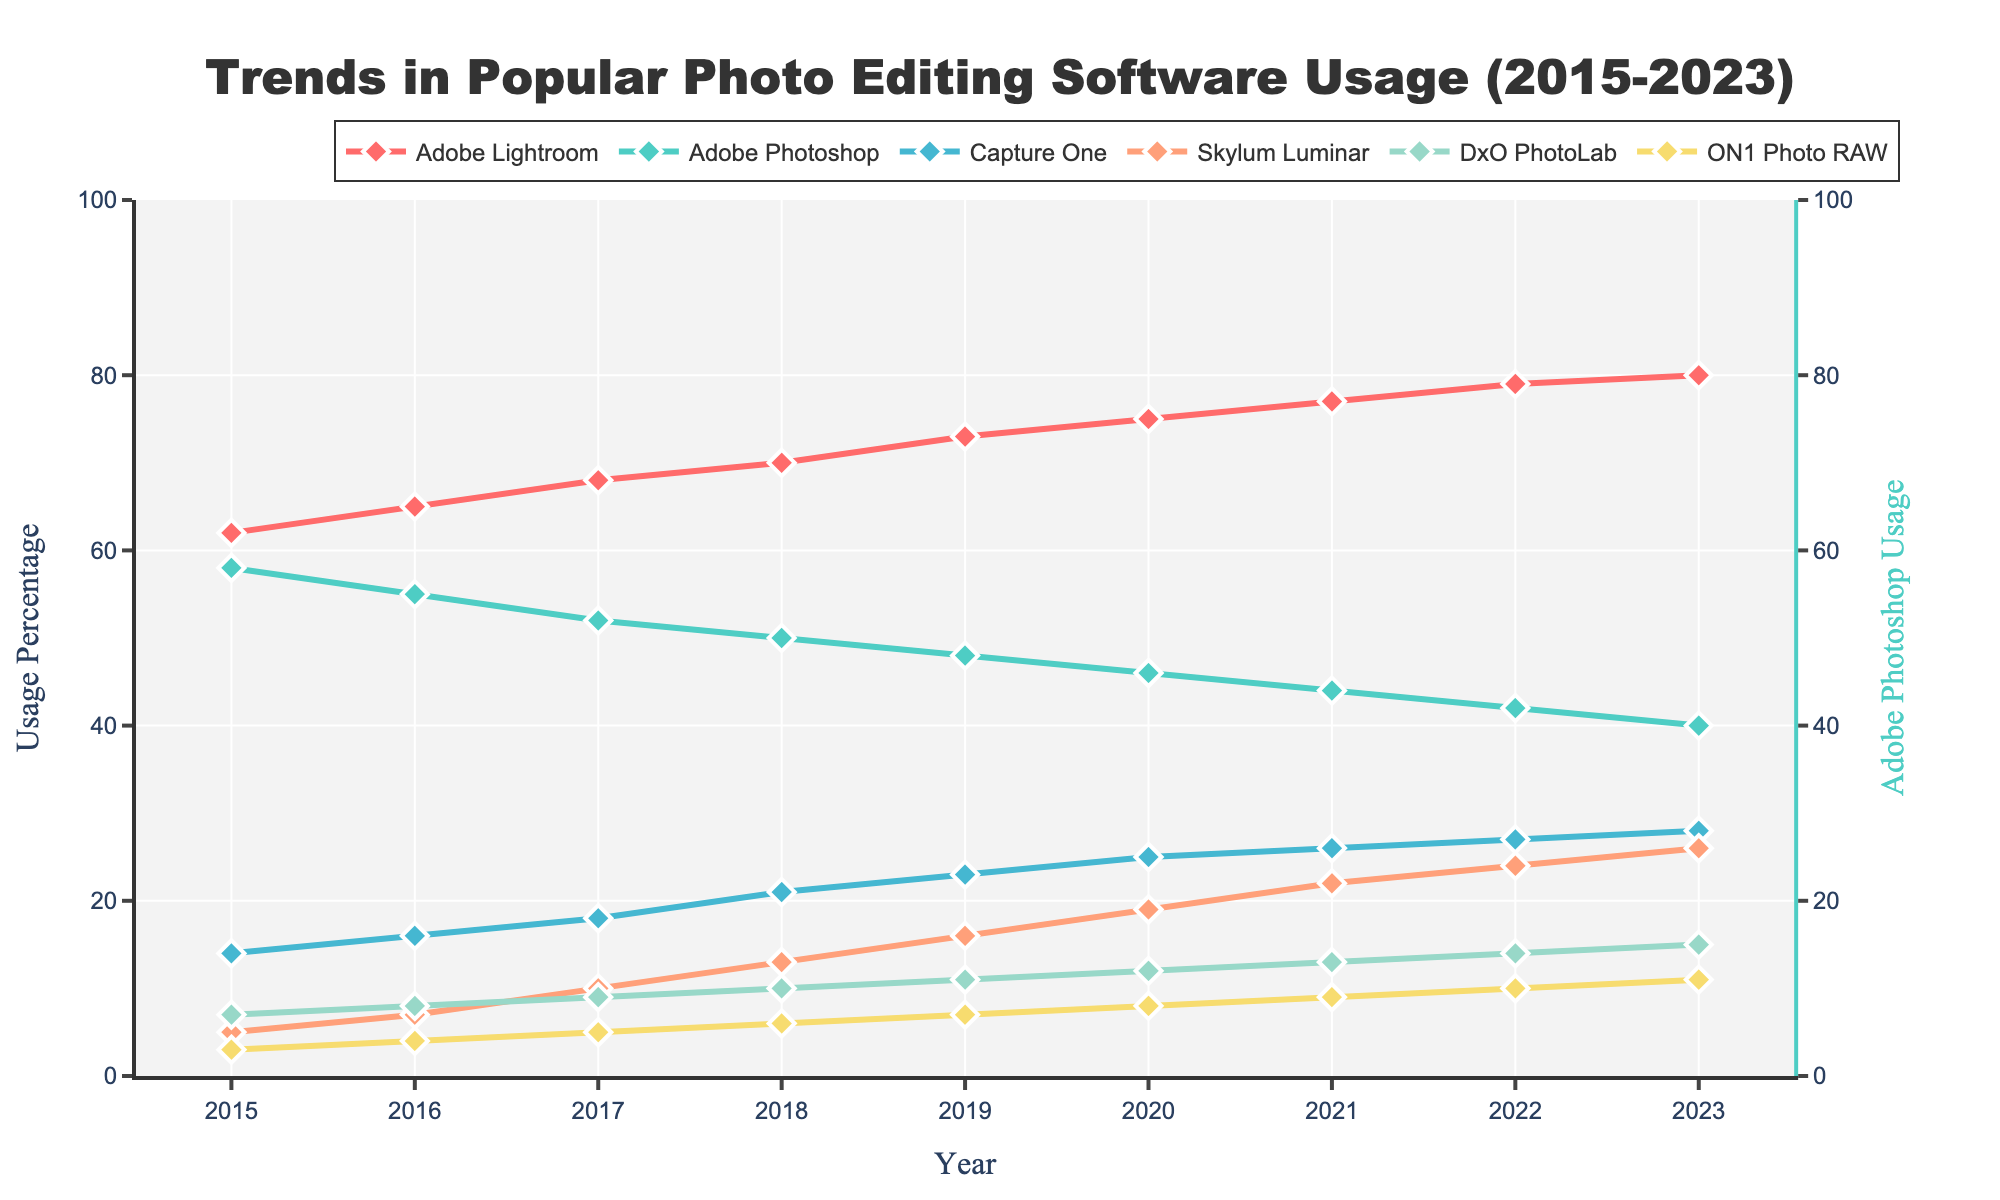What is the trend in Adobe Lightroom usage from 2015 to 2023? The line shows an upward trend where the usage of Adobe Lightroom increases each year. Starting from 62% in 2015, it steadily rises to 80% in 2023.
Answer: Increasing trend Which software has the smallest increase in usage from 2015 to 2023? By comparing the start and end points for each software, ON1 Photo RAW increases from 3% in 2015 to 11% in 2023, a gain of 8 percentage points, which is the smallest increase among the software listed.
Answer: ON1 Photo RAW How does Adobe Photoshop's usage change over the years? Adobe Photoshop's usage decreases from 58% in 2015 to 40% in 2023. The pattern shows a consistent downward trend over the years.
Answer: Decreasing trend Which two software have the highest usage percentages in 2023? By examining the endpoints for 2023, Adobe Lightroom has 80% and Adobe Photoshop has 40%, the highest among the listed software.
Answer: Adobe Lightroom and Adobe Photoshop By how much has Capture One's usage increased from 2015 to 2023? Capture One has grown from 14% in 2015 to 28% in 2023. The increase is calculated as 28% - 14% = 14 percentage points.
Answer: 14 percentage points Is there any software whose usage remained constant over the years? All the lines on the chart show either an upward or downward trend. No software shows a flat line indicating constant usage.
Answer: No What is the average usage percentage of Skylum Luminar between 2015 and 2023? The values for Skylum Luminar over the years are (5, 7, 10, 13, 16, 19, 22, 24, 26). Sum these values to get 142, then divide by the number of years, 142 / 9 ≈ 15.78%.
Answer: Approximately 15.78% Between DxO PhotoLab and ON1 Photo RAW, which had a faster growth rate from 2015 to 2023? DxO PhotoLab grows from 7% to 15% (a 8 percentage point increase) and ON1 Photo RAW grows from 3% to 11% (also an 8 percentage point increase). Both have the same growth rate over the period.
Answer: Both What is the difference in usage percentage between Adobe Lightroom and Adobe Photoshop in 2023? Adobe Lightroom is at 80% and Adobe Photoshop at 40%. The difference is 80% - 40% = 40 percentage points.
Answer: 40 percentage points Which year did Capture One reach 20% usage? Capture One surpasses 20% in 2018 as observed in the data points and corresponding lines on the chart, showing it grows to 21% that year.
Answer: 2018 